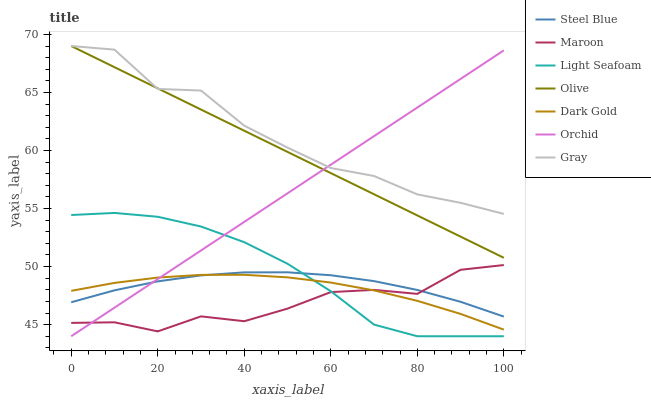Does Maroon have the minimum area under the curve?
Answer yes or no. Yes. Does Gray have the maximum area under the curve?
Answer yes or no. Yes. Does Dark Gold have the minimum area under the curve?
Answer yes or no. No. Does Dark Gold have the maximum area under the curve?
Answer yes or no. No. Is Olive the smoothest?
Answer yes or no. Yes. Is Gray the roughest?
Answer yes or no. Yes. Is Dark Gold the smoothest?
Answer yes or no. No. Is Dark Gold the roughest?
Answer yes or no. No. Does Light Seafoam have the lowest value?
Answer yes or no. Yes. Does Dark Gold have the lowest value?
Answer yes or no. No. Does Olive have the highest value?
Answer yes or no. Yes. Does Steel Blue have the highest value?
Answer yes or no. No. Is Maroon less than Gray?
Answer yes or no. Yes. Is Olive greater than Dark Gold?
Answer yes or no. Yes. Does Steel Blue intersect Orchid?
Answer yes or no. Yes. Is Steel Blue less than Orchid?
Answer yes or no. No. Is Steel Blue greater than Orchid?
Answer yes or no. No. Does Maroon intersect Gray?
Answer yes or no. No. 